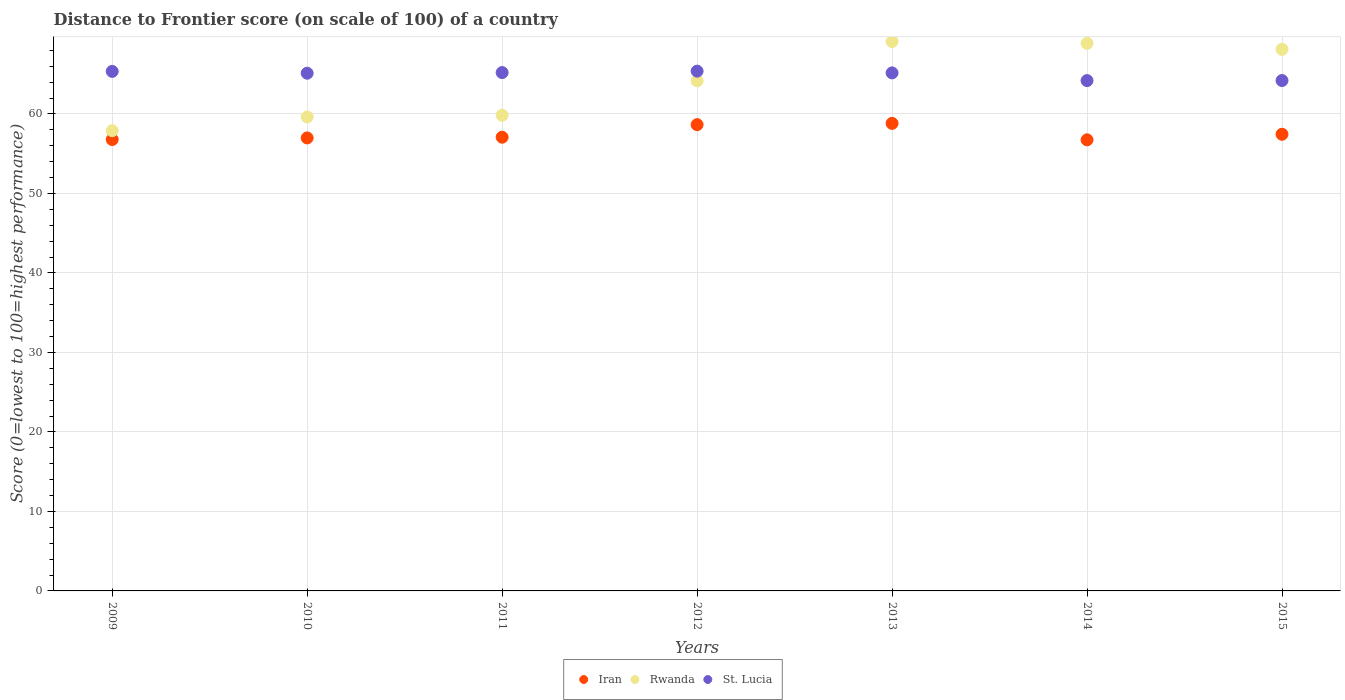How many different coloured dotlines are there?
Ensure brevity in your answer.  3. Is the number of dotlines equal to the number of legend labels?
Offer a terse response. Yes. What is the distance to frontier score of in Rwanda in 2012?
Your answer should be compact. 64.17. Across all years, what is the maximum distance to frontier score of in St. Lucia?
Ensure brevity in your answer.  65.38. Across all years, what is the minimum distance to frontier score of in St. Lucia?
Your response must be concise. 64.19. In which year was the distance to frontier score of in St. Lucia minimum?
Keep it short and to the point. 2014. What is the total distance to frontier score of in Iran in the graph?
Provide a succinct answer. 402.47. What is the difference between the distance to frontier score of in Rwanda in 2009 and that in 2011?
Provide a short and direct response. -1.94. What is the difference between the distance to frontier score of in St. Lucia in 2011 and the distance to frontier score of in Iran in 2012?
Your response must be concise. 6.55. What is the average distance to frontier score of in Rwanda per year?
Ensure brevity in your answer.  63.95. In the year 2011, what is the difference between the distance to frontier score of in St. Lucia and distance to frontier score of in Rwanda?
Ensure brevity in your answer.  5.37. In how many years, is the distance to frontier score of in St. Lucia greater than 6?
Provide a succinct answer. 7. What is the ratio of the distance to frontier score of in Rwanda in 2013 to that in 2015?
Keep it short and to the point. 1.01. What is the difference between the highest and the second highest distance to frontier score of in Rwanda?
Your response must be concise. 0.23. What is the difference between the highest and the lowest distance to frontier score of in St. Lucia?
Give a very brief answer. 1.19. Is the sum of the distance to frontier score of in Rwanda in 2010 and 2014 greater than the maximum distance to frontier score of in Iran across all years?
Keep it short and to the point. Yes. Is it the case that in every year, the sum of the distance to frontier score of in Rwanda and distance to frontier score of in St. Lucia  is greater than the distance to frontier score of in Iran?
Keep it short and to the point. Yes. Does the distance to frontier score of in Iran monotonically increase over the years?
Provide a short and direct response. No. Is the distance to frontier score of in Rwanda strictly less than the distance to frontier score of in St. Lucia over the years?
Provide a succinct answer. No. How many dotlines are there?
Give a very brief answer. 3. Does the graph contain any zero values?
Provide a short and direct response. No. How many legend labels are there?
Provide a succinct answer. 3. How are the legend labels stacked?
Ensure brevity in your answer.  Horizontal. What is the title of the graph?
Your answer should be compact. Distance to Frontier score (on scale of 100) of a country. Does "Sao Tome and Principe" appear as one of the legend labels in the graph?
Offer a terse response. No. What is the label or title of the Y-axis?
Provide a succinct answer. Score (0=lowest to 100=highest performance). What is the Score (0=lowest to 100=highest performance) of Iran in 2009?
Offer a very short reply. 56.78. What is the Score (0=lowest to 100=highest performance) in Rwanda in 2009?
Ensure brevity in your answer.  57.89. What is the Score (0=lowest to 100=highest performance) of St. Lucia in 2009?
Your answer should be compact. 65.35. What is the Score (0=lowest to 100=highest performance) in Iran in 2010?
Make the answer very short. 56.98. What is the Score (0=lowest to 100=highest performance) in Rwanda in 2010?
Ensure brevity in your answer.  59.62. What is the Score (0=lowest to 100=highest performance) of St. Lucia in 2010?
Your response must be concise. 65.12. What is the Score (0=lowest to 100=highest performance) of Iran in 2011?
Your answer should be compact. 57.07. What is the Score (0=lowest to 100=highest performance) in Rwanda in 2011?
Provide a short and direct response. 59.83. What is the Score (0=lowest to 100=highest performance) of St. Lucia in 2011?
Ensure brevity in your answer.  65.2. What is the Score (0=lowest to 100=highest performance) of Iran in 2012?
Keep it short and to the point. 58.65. What is the Score (0=lowest to 100=highest performance) in Rwanda in 2012?
Provide a short and direct response. 64.17. What is the Score (0=lowest to 100=highest performance) in St. Lucia in 2012?
Your answer should be very brief. 65.38. What is the Score (0=lowest to 100=highest performance) in Iran in 2013?
Give a very brief answer. 58.81. What is the Score (0=lowest to 100=highest performance) in Rwanda in 2013?
Make the answer very short. 69.11. What is the Score (0=lowest to 100=highest performance) in St. Lucia in 2013?
Your answer should be compact. 65.16. What is the Score (0=lowest to 100=highest performance) in Iran in 2014?
Your answer should be compact. 56.74. What is the Score (0=lowest to 100=highest performance) of Rwanda in 2014?
Keep it short and to the point. 68.88. What is the Score (0=lowest to 100=highest performance) in St. Lucia in 2014?
Your answer should be very brief. 64.19. What is the Score (0=lowest to 100=highest performance) of Iran in 2015?
Offer a very short reply. 57.44. What is the Score (0=lowest to 100=highest performance) in Rwanda in 2015?
Your response must be concise. 68.12. What is the Score (0=lowest to 100=highest performance) of St. Lucia in 2015?
Offer a very short reply. 64.2. Across all years, what is the maximum Score (0=lowest to 100=highest performance) in Iran?
Provide a short and direct response. 58.81. Across all years, what is the maximum Score (0=lowest to 100=highest performance) in Rwanda?
Ensure brevity in your answer.  69.11. Across all years, what is the maximum Score (0=lowest to 100=highest performance) in St. Lucia?
Provide a short and direct response. 65.38. Across all years, what is the minimum Score (0=lowest to 100=highest performance) in Iran?
Give a very brief answer. 56.74. Across all years, what is the minimum Score (0=lowest to 100=highest performance) in Rwanda?
Your answer should be very brief. 57.89. Across all years, what is the minimum Score (0=lowest to 100=highest performance) in St. Lucia?
Make the answer very short. 64.19. What is the total Score (0=lowest to 100=highest performance) of Iran in the graph?
Keep it short and to the point. 402.47. What is the total Score (0=lowest to 100=highest performance) in Rwanda in the graph?
Provide a succinct answer. 447.62. What is the total Score (0=lowest to 100=highest performance) of St. Lucia in the graph?
Your answer should be compact. 454.6. What is the difference between the Score (0=lowest to 100=highest performance) of Rwanda in 2009 and that in 2010?
Make the answer very short. -1.73. What is the difference between the Score (0=lowest to 100=highest performance) in St. Lucia in 2009 and that in 2010?
Provide a succinct answer. 0.23. What is the difference between the Score (0=lowest to 100=highest performance) of Iran in 2009 and that in 2011?
Provide a succinct answer. -0.29. What is the difference between the Score (0=lowest to 100=highest performance) in Rwanda in 2009 and that in 2011?
Your answer should be compact. -1.94. What is the difference between the Score (0=lowest to 100=highest performance) in St. Lucia in 2009 and that in 2011?
Your answer should be very brief. 0.15. What is the difference between the Score (0=lowest to 100=highest performance) of Iran in 2009 and that in 2012?
Make the answer very short. -1.87. What is the difference between the Score (0=lowest to 100=highest performance) in Rwanda in 2009 and that in 2012?
Provide a succinct answer. -6.28. What is the difference between the Score (0=lowest to 100=highest performance) of St. Lucia in 2009 and that in 2012?
Offer a terse response. -0.03. What is the difference between the Score (0=lowest to 100=highest performance) in Iran in 2009 and that in 2013?
Provide a succinct answer. -2.03. What is the difference between the Score (0=lowest to 100=highest performance) in Rwanda in 2009 and that in 2013?
Your answer should be compact. -11.22. What is the difference between the Score (0=lowest to 100=highest performance) in St. Lucia in 2009 and that in 2013?
Your response must be concise. 0.19. What is the difference between the Score (0=lowest to 100=highest performance) of Rwanda in 2009 and that in 2014?
Provide a succinct answer. -10.99. What is the difference between the Score (0=lowest to 100=highest performance) in St. Lucia in 2009 and that in 2014?
Offer a terse response. 1.16. What is the difference between the Score (0=lowest to 100=highest performance) in Iran in 2009 and that in 2015?
Your response must be concise. -0.66. What is the difference between the Score (0=lowest to 100=highest performance) in Rwanda in 2009 and that in 2015?
Make the answer very short. -10.23. What is the difference between the Score (0=lowest to 100=highest performance) of St. Lucia in 2009 and that in 2015?
Make the answer very short. 1.15. What is the difference between the Score (0=lowest to 100=highest performance) of Iran in 2010 and that in 2011?
Your answer should be very brief. -0.09. What is the difference between the Score (0=lowest to 100=highest performance) in Rwanda in 2010 and that in 2011?
Provide a short and direct response. -0.21. What is the difference between the Score (0=lowest to 100=highest performance) in St. Lucia in 2010 and that in 2011?
Offer a terse response. -0.08. What is the difference between the Score (0=lowest to 100=highest performance) in Iran in 2010 and that in 2012?
Keep it short and to the point. -1.67. What is the difference between the Score (0=lowest to 100=highest performance) in Rwanda in 2010 and that in 2012?
Your answer should be very brief. -4.55. What is the difference between the Score (0=lowest to 100=highest performance) of St. Lucia in 2010 and that in 2012?
Offer a terse response. -0.26. What is the difference between the Score (0=lowest to 100=highest performance) in Iran in 2010 and that in 2013?
Your answer should be compact. -1.83. What is the difference between the Score (0=lowest to 100=highest performance) of Rwanda in 2010 and that in 2013?
Your answer should be very brief. -9.49. What is the difference between the Score (0=lowest to 100=highest performance) of St. Lucia in 2010 and that in 2013?
Your answer should be very brief. -0.04. What is the difference between the Score (0=lowest to 100=highest performance) in Iran in 2010 and that in 2014?
Your answer should be very brief. 0.24. What is the difference between the Score (0=lowest to 100=highest performance) of Rwanda in 2010 and that in 2014?
Offer a very short reply. -9.26. What is the difference between the Score (0=lowest to 100=highest performance) of St. Lucia in 2010 and that in 2014?
Provide a succinct answer. 0.93. What is the difference between the Score (0=lowest to 100=highest performance) of Iran in 2010 and that in 2015?
Your response must be concise. -0.46. What is the difference between the Score (0=lowest to 100=highest performance) in St. Lucia in 2010 and that in 2015?
Provide a short and direct response. 0.92. What is the difference between the Score (0=lowest to 100=highest performance) of Iran in 2011 and that in 2012?
Offer a terse response. -1.58. What is the difference between the Score (0=lowest to 100=highest performance) of Rwanda in 2011 and that in 2012?
Give a very brief answer. -4.34. What is the difference between the Score (0=lowest to 100=highest performance) in St. Lucia in 2011 and that in 2012?
Provide a short and direct response. -0.18. What is the difference between the Score (0=lowest to 100=highest performance) in Iran in 2011 and that in 2013?
Offer a terse response. -1.74. What is the difference between the Score (0=lowest to 100=highest performance) of Rwanda in 2011 and that in 2013?
Ensure brevity in your answer.  -9.28. What is the difference between the Score (0=lowest to 100=highest performance) of St. Lucia in 2011 and that in 2013?
Offer a very short reply. 0.04. What is the difference between the Score (0=lowest to 100=highest performance) of Iran in 2011 and that in 2014?
Give a very brief answer. 0.33. What is the difference between the Score (0=lowest to 100=highest performance) in Rwanda in 2011 and that in 2014?
Make the answer very short. -9.05. What is the difference between the Score (0=lowest to 100=highest performance) of St. Lucia in 2011 and that in 2014?
Your response must be concise. 1.01. What is the difference between the Score (0=lowest to 100=highest performance) of Iran in 2011 and that in 2015?
Provide a succinct answer. -0.37. What is the difference between the Score (0=lowest to 100=highest performance) in Rwanda in 2011 and that in 2015?
Give a very brief answer. -8.29. What is the difference between the Score (0=lowest to 100=highest performance) in Iran in 2012 and that in 2013?
Offer a very short reply. -0.16. What is the difference between the Score (0=lowest to 100=highest performance) of Rwanda in 2012 and that in 2013?
Provide a short and direct response. -4.94. What is the difference between the Score (0=lowest to 100=highest performance) of St. Lucia in 2012 and that in 2013?
Offer a terse response. 0.22. What is the difference between the Score (0=lowest to 100=highest performance) in Iran in 2012 and that in 2014?
Keep it short and to the point. 1.91. What is the difference between the Score (0=lowest to 100=highest performance) in Rwanda in 2012 and that in 2014?
Your answer should be compact. -4.71. What is the difference between the Score (0=lowest to 100=highest performance) of St. Lucia in 2012 and that in 2014?
Keep it short and to the point. 1.19. What is the difference between the Score (0=lowest to 100=highest performance) of Iran in 2012 and that in 2015?
Provide a succinct answer. 1.21. What is the difference between the Score (0=lowest to 100=highest performance) of Rwanda in 2012 and that in 2015?
Make the answer very short. -3.95. What is the difference between the Score (0=lowest to 100=highest performance) in St. Lucia in 2012 and that in 2015?
Offer a terse response. 1.18. What is the difference between the Score (0=lowest to 100=highest performance) of Iran in 2013 and that in 2014?
Offer a very short reply. 2.07. What is the difference between the Score (0=lowest to 100=highest performance) in Rwanda in 2013 and that in 2014?
Provide a short and direct response. 0.23. What is the difference between the Score (0=lowest to 100=highest performance) in Iran in 2013 and that in 2015?
Your answer should be compact. 1.37. What is the difference between the Score (0=lowest to 100=highest performance) in Rwanda in 2013 and that in 2015?
Provide a succinct answer. 0.99. What is the difference between the Score (0=lowest to 100=highest performance) in Iran in 2014 and that in 2015?
Your answer should be compact. -0.7. What is the difference between the Score (0=lowest to 100=highest performance) of Rwanda in 2014 and that in 2015?
Offer a terse response. 0.76. What is the difference between the Score (0=lowest to 100=highest performance) of St. Lucia in 2014 and that in 2015?
Provide a succinct answer. -0.01. What is the difference between the Score (0=lowest to 100=highest performance) in Iran in 2009 and the Score (0=lowest to 100=highest performance) in Rwanda in 2010?
Ensure brevity in your answer.  -2.84. What is the difference between the Score (0=lowest to 100=highest performance) in Iran in 2009 and the Score (0=lowest to 100=highest performance) in St. Lucia in 2010?
Offer a very short reply. -8.34. What is the difference between the Score (0=lowest to 100=highest performance) of Rwanda in 2009 and the Score (0=lowest to 100=highest performance) of St. Lucia in 2010?
Make the answer very short. -7.23. What is the difference between the Score (0=lowest to 100=highest performance) of Iran in 2009 and the Score (0=lowest to 100=highest performance) of Rwanda in 2011?
Give a very brief answer. -3.05. What is the difference between the Score (0=lowest to 100=highest performance) in Iran in 2009 and the Score (0=lowest to 100=highest performance) in St. Lucia in 2011?
Your response must be concise. -8.42. What is the difference between the Score (0=lowest to 100=highest performance) in Rwanda in 2009 and the Score (0=lowest to 100=highest performance) in St. Lucia in 2011?
Make the answer very short. -7.31. What is the difference between the Score (0=lowest to 100=highest performance) of Iran in 2009 and the Score (0=lowest to 100=highest performance) of Rwanda in 2012?
Your answer should be compact. -7.39. What is the difference between the Score (0=lowest to 100=highest performance) in Iran in 2009 and the Score (0=lowest to 100=highest performance) in St. Lucia in 2012?
Give a very brief answer. -8.6. What is the difference between the Score (0=lowest to 100=highest performance) in Rwanda in 2009 and the Score (0=lowest to 100=highest performance) in St. Lucia in 2012?
Your answer should be very brief. -7.49. What is the difference between the Score (0=lowest to 100=highest performance) in Iran in 2009 and the Score (0=lowest to 100=highest performance) in Rwanda in 2013?
Provide a succinct answer. -12.33. What is the difference between the Score (0=lowest to 100=highest performance) of Iran in 2009 and the Score (0=lowest to 100=highest performance) of St. Lucia in 2013?
Ensure brevity in your answer.  -8.38. What is the difference between the Score (0=lowest to 100=highest performance) of Rwanda in 2009 and the Score (0=lowest to 100=highest performance) of St. Lucia in 2013?
Keep it short and to the point. -7.27. What is the difference between the Score (0=lowest to 100=highest performance) of Iran in 2009 and the Score (0=lowest to 100=highest performance) of St. Lucia in 2014?
Offer a very short reply. -7.41. What is the difference between the Score (0=lowest to 100=highest performance) in Rwanda in 2009 and the Score (0=lowest to 100=highest performance) in St. Lucia in 2014?
Your answer should be very brief. -6.3. What is the difference between the Score (0=lowest to 100=highest performance) in Iran in 2009 and the Score (0=lowest to 100=highest performance) in Rwanda in 2015?
Your response must be concise. -11.34. What is the difference between the Score (0=lowest to 100=highest performance) of Iran in 2009 and the Score (0=lowest to 100=highest performance) of St. Lucia in 2015?
Your answer should be very brief. -7.42. What is the difference between the Score (0=lowest to 100=highest performance) in Rwanda in 2009 and the Score (0=lowest to 100=highest performance) in St. Lucia in 2015?
Offer a very short reply. -6.31. What is the difference between the Score (0=lowest to 100=highest performance) in Iran in 2010 and the Score (0=lowest to 100=highest performance) in Rwanda in 2011?
Your answer should be compact. -2.85. What is the difference between the Score (0=lowest to 100=highest performance) in Iran in 2010 and the Score (0=lowest to 100=highest performance) in St. Lucia in 2011?
Keep it short and to the point. -8.22. What is the difference between the Score (0=lowest to 100=highest performance) in Rwanda in 2010 and the Score (0=lowest to 100=highest performance) in St. Lucia in 2011?
Give a very brief answer. -5.58. What is the difference between the Score (0=lowest to 100=highest performance) in Iran in 2010 and the Score (0=lowest to 100=highest performance) in Rwanda in 2012?
Provide a succinct answer. -7.19. What is the difference between the Score (0=lowest to 100=highest performance) of Iran in 2010 and the Score (0=lowest to 100=highest performance) of St. Lucia in 2012?
Make the answer very short. -8.4. What is the difference between the Score (0=lowest to 100=highest performance) of Rwanda in 2010 and the Score (0=lowest to 100=highest performance) of St. Lucia in 2012?
Give a very brief answer. -5.76. What is the difference between the Score (0=lowest to 100=highest performance) in Iran in 2010 and the Score (0=lowest to 100=highest performance) in Rwanda in 2013?
Your response must be concise. -12.13. What is the difference between the Score (0=lowest to 100=highest performance) in Iran in 2010 and the Score (0=lowest to 100=highest performance) in St. Lucia in 2013?
Provide a succinct answer. -8.18. What is the difference between the Score (0=lowest to 100=highest performance) of Rwanda in 2010 and the Score (0=lowest to 100=highest performance) of St. Lucia in 2013?
Your answer should be compact. -5.54. What is the difference between the Score (0=lowest to 100=highest performance) in Iran in 2010 and the Score (0=lowest to 100=highest performance) in Rwanda in 2014?
Provide a succinct answer. -11.9. What is the difference between the Score (0=lowest to 100=highest performance) in Iran in 2010 and the Score (0=lowest to 100=highest performance) in St. Lucia in 2014?
Offer a terse response. -7.21. What is the difference between the Score (0=lowest to 100=highest performance) in Rwanda in 2010 and the Score (0=lowest to 100=highest performance) in St. Lucia in 2014?
Make the answer very short. -4.57. What is the difference between the Score (0=lowest to 100=highest performance) in Iran in 2010 and the Score (0=lowest to 100=highest performance) in Rwanda in 2015?
Provide a short and direct response. -11.14. What is the difference between the Score (0=lowest to 100=highest performance) in Iran in 2010 and the Score (0=lowest to 100=highest performance) in St. Lucia in 2015?
Your response must be concise. -7.22. What is the difference between the Score (0=lowest to 100=highest performance) in Rwanda in 2010 and the Score (0=lowest to 100=highest performance) in St. Lucia in 2015?
Offer a terse response. -4.58. What is the difference between the Score (0=lowest to 100=highest performance) of Iran in 2011 and the Score (0=lowest to 100=highest performance) of Rwanda in 2012?
Your response must be concise. -7.1. What is the difference between the Score (0=lowest to 100=highest performance) in Iran in 2011 and the Score (0=lowest to 100=highest performance) in St. Lucia in 2012?
Keep it short and to the point. -8.31. What is the difference between the Score (0=lowest to 100=highest performance) of Rwanda in 2011 and the Score (0=lowest to 100=highest performance) of St. Lucia in 2012?
Your answer should be very brief. -5.55. What is the difference between the Score (0=lowest to 100=highest performance) of Iran in 2011 and the Score (0=lowest to 100=highest performance) of Rwanda in 2013?
Offer a terse response. -12.04. What is the difference between the Score (0=lowest to 100=highest performance) in Iran in 2011 and the Score (0=lowest to 100=highest performance) in St. Lucia in 2013?
Keep it short and to the point. -8.09. What is the difference between the Score (0=lowest to 100=highest performance) in Rwanda in 2011 and the Score (0=lowest to 100=highest performance) in St. Lucia in 2013?
Make the answer very short. -5.33. What is the difference between the Score (0=lowest to 100=highest performance) of Iran in 2011 and the Score (0=lowest to 100=highest performance) of Rwanda in 2014?
Provide a succinct answer. -11.81. What is the difference between the Score (0=lowest to 100=highest performance) in Iran in 2011 and the Score (0=lowest to 100=highest performance) in St. Lucia in 2014?
Give a very brief answer. -7.12. What is the difference between the Score (0=lowest to 100=highest performance) in Rwanda in 2011 and the Score (0=lowest to 100=highest performance) in St. Lucia in 2014?
Provide a succinct answer. -4.36. What is the difference between the Score (0=lowest to 100=highest performance) of Iran in 2011 and the Score (0=lowest to 100=highest performance) of Rwanda in 2015?
Provide a succinct answer. -11.05. What is the difference between the Score (0=lowest to 100=highest performance) of Iran in 2011 and the Score (0=lowest to 100=highest performance) of St. Lucia in 2015?
Offer a very short reply. -7.13. What is the difference between the Score (0=lowest to 100=highest performance) of Rwanda in 2011 and the Score (0=lowest to 100=highest performance) of St. Lucia in 2015?
Your answer should be compact. -4.37. What is the difference between the Score (0=lowest to 100=highest performance) of Iran in 2012 and the Score (0=lowest to 100=highest performance) of Rwanda in 2013?
Provide a short and direct response. -10.46. What is the difference between the Score (0=lowest to 100=highest performance) in Iran in 2012 and the Score (0=lowest to 100=highest performance) in St. Lucia in 2013?
Your answer should be compact. -6.51. What is the difference between the Score (0=lowest to 100=highest performance) in Rwanda in 2012 and the Score (0=lowest to 100=highest performance) in St. Lucia in 2013?
Give a very brief answer. -0.99. What is the difference between the Score (0=lowest to 100=highest performance) in Iran in 2012 and the Score (0=lowest to 100=highest performance) in Rwanda in 2014?
Your response must be concise. -10.23. What is the difference between the Score (0=lowest to 100=highest performance) in Iran in 2012 and the Score (0=lowest to 100=highest performance) in St. Lucia in 2014?
Offer a very short reply. -5.54. What is the difference between the Score (0=lowest to 100=highest performance) in Rwanda in 2012 and the Score (0=lowest to 100=highest performance) in St. Lucia in 2014?
Make the answer very short. -0.02. What is the difference between the Score (0=lowest to 100=highest performance) in Iran in 2012 and the Score (0=lowest to 100=highest performance) in Rwanda in 2015?
Offer a terse response. -9.47. What is the difference between the Score (0=lowest to 100=highest performance) of Iran in 2012 and the Score (0=lowest to 100=highest performance) of St. Lucia in 2015?
Your response must be concise. -5.55. What is the difference between the Score (0=lowest to 100=highest performance) of Rwanda in 2012 and the Score (0=lowest to 100=highest performance) of St. Lucia in 2015?
Ensure brevity in your answer.  -0.03. What is the difference between the Score (0=lowest to 100=highest performance) in Iran in 2013 and the Score (0=lowest to 100=highest performance) in Rwanda in 2014?
Offer a terse response. -10.07. What is the difference between the Score (0=lowest to 100=highest performance) in Iran in 2013 and the Score (0=lowest to 100=highest performance) in St. Lucia in 2014?
Keep it short and to the point. -5.38. What is the difference between the Score (0=lowest to 100=highest performance) in Rwanda in 2013 and the Score (0=lowest to 100=highest performance) in St. Lucia in 2014?
Offer a terse response. 4.92. What is the difference between the Score (0=lowest to 100=highest performance) in Iran in 2013 and the Score (0=lowest to 100=highest performance) in Rwanda in 2015?
Provide a succinct answer. -9.31. What is the difference between the Score (0=lowest to 100=highest performance) of Iran in 2013 and the Score (0=lowest to 100=highest performance) of St. Lucia in 2015?
Provide a short and direct response. -5.39. What is the difference between the Score (0=lowest to 100=highest performance) in Rwanda in 2013 and the Score (0=lowest to 100=highest performance) in St. Lucia in 2015?
Provide a short and direct response. 4.91. What is the difference between the Score (0=lowest to 100=highest performance) in Iran in 2014 and the Score (0=lowest to 100=highest performance) in Rwanda in 2015?
Keep it short and to the point. -11.38. What is the difference between the Score (0=lowest to 100=highest performance) of Iran in 2014 and the Score (0=lowest to 100=highest performance) of St. Lucia in 2015?
Keep it short and to the point. -7.46. What is the difference between the Score (0=lowest to 100=highest performance) in Rwanda in 2014 and the Score (0=lowest to 100=highest performance) in St. Lucia in 2015?
Your answer should be very brief. 4.68. What is the average Score (0=lowest to 100=highest performance) in Iran per year?
Provide a short and direct response. 57.5. What is the average Score (0=lowest to 100=highest performance) in Rwanda per year?
Your response must be concise. 63.95. What is the average Score (0=lowest to 100=highest performance) of St. Lucia per year?
Ensure brevity in your answer.  64.94. In the year 2009, what is the difference between the Score (0=lowest to 100=highest performance) in Iran and Score (0=lowest to 100=highest performance) in Rwanda?
Your answer should be very brief. -1.11. In the year 2009, what is the difference between the Score (0=lowest to 100=highest performance) of Iran and Score (0=lowest to 100=highest performance) of St. Lucia?
Provide a short and direct response. -8.57. In the year 2009, what is the difference between the Score (0=lowest to 100=highest performance) of Rwanda and Score (0=lowest to 100=highest performance) of St. Lucia?
Ensure brevity in your answer.  -7.46. In the year 2010, what is the difference between the Score (0=lowest to 100=highest performance) in Iran and Score (0=lowest to 100=highest performance) in Rwanda?
Give a very brief answer. -2.64. In the year 2010, what is the difference between the Score (0=lowest to 100=highest performance) in Iran and Score (0=lowest to 100=highest performance) in St. Lucia?
Your answer should be very brief. -8.14. In the year 2010, what is the difference between the Score (0=lowest to 100=highest performance) of Rwanda and Score (0=lowest to 100=highest performance) of St. Lucia?
Ensure brevity in your answer.  -5.5. In the year 2011, what is the difference between the Score (0=lowest to 100=highest performance) in Iran and Score (0=lowest to 100=highest performance) in Rwanda?
Keep it short and to the point. -2.76. In the year 2011, what is the difference between the Score (0=lowest to 100=highest performance) of Iran and Score (0=lowest to 100=highest performance) of St. Lucia?
Your answer should be very brief. -8.13. In the year 2011, what is the difference between the Score (0=lowest to 100=highest performance) in Rwanda and Score (0=lowest to 100=highest performance) in St. Lucia?
Make the answer very short. -5.37. In the year 2012, what is the difference between the Score (0=lowest to 100=highest performance) of Iran and Score (0=lowest to 100=highest performance) of Rwanda?
Your answer should be very brief. -5.52. In the year 2012, what is the difference between the Score (0=lowest to 100=highest performance) of Iran and Score (0=lowest to 100=highest performance) of St. Lucia?
Provide a short and direct response. -6.73. In the year 2012, what is the difference between the Score (0=lowest to 100=highest performance) in Rwanda and Score (0=lowest to 100=highest performance) in St. Lucia?
Provide a succinct answer. -1.21. In the year 2013, what is the difference between the Score (0=lowest to 100=highest performance) in Iran and Score (0=lowest to 100=highest performance) in St. Lucia?
Provide a short and direct response. -6.35. In the year 2013, what is the difference between the Score (0=lowest to 100=highest performance) in Rwanda and Score (0=lowest to 100=highest performance) in St. Lucia?
Your response must be concise. 3.95. In the year 2014, what is the difference between the Score (0=lowest to 100=highest performance) of Iran and Score (0=lowest to 100=highest performance) of Rwanda?
Provide a succinct answer. -12.14. In the year 2014, what is the difference between the Score (0=lowest to 100=highest performance) of Iran and Score (0=lowest to 100=highest performance) of St. Lucia?
Provide a succinct answer. -7.45. In the year 2014, what is the difference between the Score (0=lowest to 100=highest performance) in Rwanda and Score (0=lowest to 100=highest performance) in St. Lucia?
Your answer should be compact. 4.69. In the year 2015, what is the difference between the Score (0=lowest to 100=highest performance) of Iran and Score (0=lowest to 100=highest performance) of Rwanda?
Your answer should be very brief. -10.68. In the year 2015, what is the difference between the Score (0=lowest to 100=highest performance) in Iran and Score (0=lowest to 100=highest performance) in St. Lucia?
Your answer should be compact. -6.76. In the year 2015, what is the difference between the Score (0=lowest to 100=highest performance) of Rwanda and Score (0=lowest to 100=highest performance) of St. Lucia?
Provide a short and direct response. 3.92. What is the ratio of the Score (0=lowest to 100=highest performance) in Iran in 2009 to that in 2010?
Keep it short and to the point. 1. What is the ratio of the Score (0=lowest to 100=highest performance) in Iran in 2009 to that in 2011?
Your answer should be compact. 0.99. What is the ratio of the Score (0=lowest to 100=highest performance) of Rwanda in 2009 to that in 2011?
Make the answer very short. 0.97. What is the ratio of the Score (0=lowest to 100=highest performance) of Iran in 2009 to that in 2012?
Your answer should be compact. 0.97. What is the ratio of the Score (0=lowest to 100=highest performance) of Rwanda in 2009 to that in 2012?
Offer a very short reply. 0.9. What is the ratio of the Score (0=lowest to 100=highest performance) of Iran in 2009 to that in 2013?
Provide a succinct answer. 0.97. What is the ratio of the Score (0=lowest to 100=highest performance) of Rwanda in 2009 to that in 2013?
Your response must be concise. 0.84. What is the ratio of the Score (0=lowest to 100=highest performance) in Rwanda in 2009 to that in 2014?
Offer a very short reply. 0.84. What is the ratio of the Score (0=lowest to 100=highest performance) of St. Lucia in 2009 to that in 2014?
Your answer should be very brief. 1.02. What is the ratio of the Score (0=lowest to 100=highest performance) in Rwanda in 2009 to that in 2015?
Your answer should be very brief. 0.85. What is the ratio of the Score (0=lowest to 100=highest performance) in St. Lucia in 2009 to that in 2015?
Your response must be concise. 1.02. What is the ratio of the Score (0=lowest to 100=highest performance) in Rwanda in 2010 to that in 2011?
Provide a short and direct response. 1. What is the ratio of the Score (0=lowest to 100=highest performance) of St. Lucia in 2010 to that in 2011?
Offer a very short reply. 1. What is the ratio of the Score (0=lowest to 100=highest performance) of Iran in 2010 to that in 2012?
Your response must be concise. 0.97. What is the ratio of the Score (0=lowest to 100=highest performance) in Rwanda in 2010 to that in 2012?
Provide a succinct answer. 0.93. What is the ratio of the Score (0=lowest to 100=highest performance) of Iran in 2010 to that in 2013?
Ensure brevity in your answer.  0.97. What is the ratio of the Score (0=lowest to 100=highest performance) in Rwanda in 2010 to that in 2013?
Give a very brief answer. 0.86. What is the ratio of the Score (0=lowest to 100=highest performance) of Rwanda in 2010 to that in 2014?
Your answer should be compact. 0.87. What is the ratio of the Score (0=lowest to 100=highest performance) in St. Lucia in 2010 to that in 2014?
Keep it short and to the point. 1.01. What is the ratio of the Score (0=lowest to 100=highest performance) of Iran in 2010 to that in 2015?
Ensure brevity in your answer.  0.99. What is the ratio of the Score (0=lowest to 100=highest performance) of Rwanda in 2010 to that in 2015?
Provide a short and direct response. 0.88. What is the ratio of the Score (0=lowest to 100=highest performance) of St. Lucia in 2010 to that in 2015?
Your response must be concise. 1.01. What is the ratio of the Score (0=lowest to 100=highest performance) in Iran in 2011 to that in 2012?
Offer a very short reply. 0.97. What is the ratio of the Score (0=lowest to 100=highest performance) in Rwanda in 2011 to that in 2012?
Offer a terse response. 0.93. What is the ratio of the Score (0=lowest to 100=highest performance) of Iran in 2011 to that in 2013?
Give a very brief answer. 0.97. What is the ratio of the Score (0=lowest to 100=highest performance) in Rwanda in 2011 to that in 2013?
Make the answer very short. 0.87. What is the ratio of the Score (0=lowest to 100=highest performance) in Rwanda in 2011 to that in 2014?
Your response must be concise. 0.87. What is the ratio of the Score (0=lowest to 100=highest performance) in St. Lucia in 2011 to that in 2014?
Offer a very short reply. 1.02. What is the ratio of the Score (0=lowest to 100=highest performance) of Rwanda in 2011 to that in 2015?
Provide a succinct answer. 0.88. What is the ratio of the Score (0=lowest to 100=highest performance) of St. Lucia in 2011 to that in 2015?
Ensure brevity in your answer.  1.02. What is the ratio of the Score (0=lowest to 100=highest performance) of Rwanda in 2012 to that in 2013?
Offer a terse response. 0.93. What is the ratio of the Score (0=lowest to 100=highest performance) of Iran in 2012 to that in 2014?
Your answer should be very brief. 1.03. What is the ratio of the Score (0=lowest to 100=highest performance) of Rwanda in 2012 to that in 2014?
Ensure brevity in your answer.  0.93. What is the ratio of the Score (0=lowest to 100=highest performance) of St. Lucia in 2012 to that in 2014?
Keep it short and to the point. 1.02. What is the ratio of the Score (0=lowest to 100=highest performance) in Iran in 2012 to that in 2015?
Keep it short and to the point. 1.02. What is the ratio of the Score (0=lowest to 100=highest performance) of Rwanda in 2012 to that in 2015?
Your response must be concise. 0.94. What is the ratio of the Score (0=lowest to 100=highest performance) of St. Lucia in 2012 to that in 2015?
Offer a very short reply. 1.02. What is the ratio of the Score (0=lowest to 100=highest performance) in Iran in 2013 to that in 2014?
Make the answer very short. 1.04. What is the ratio of the Score (0=lowest to 100=highest performance) of Rwanda in 2013 to that in 2014?
Your answer should be compact. 1. What is the ratio of the Score (0=lowest to 100=highest performance) of St. Lucia in 2013 to that in 2014?
Offer a very short reply. 1.02. What is the ratio of the Score (0=lowest to 100=highest performance) in Iran in 2013 to that in 2015?
Offer a very short reply. 1.02. What is the ratio of the Score (0=lowest to 100=highest performance) in Rwanda in 2013 to that in 2015?
Keep it short and to the point. 1.01. What is the ratio of the Score (0=lowest to 100=highest performance) in St. Lucia in 2013 to that in 2015?
Provide a short and direct response. 1.01. What is the ratio of the Score (0=lowest to 100=highest performance) of Rwanda in 2014 to that in 2015?
Ensure brevity in your answer.  1.01. What is the difference between the highest and the second highest Score (0=lowest to 100=highest performance) in Iran?
Provide a succinct answer. 0.16. What is the difference between the highest and the second highest Score (0=lowest to 100=highest performance) in Rwanda?
Ensure brevity in your answer.  0.23. What is the difference between the highest and the second highest Score (0=lowest to 100=highest performance) in St. Lucia?
Provide a short and direct response. 0.03. What is the difference between the highest and the lowest Score (0=lowest to 100=highest performance) of Iran?
Provide a short and direct response. 2.07. What is the difference between the highest and the lowest Score (0=lowest to 100=highest performance) of Rwanda?
Your answer should be compact. 11.22. What is the difference between the highest and the lowest Score (0=lowest to 100=highest performance) in St. Lucia?
Provide a succinct answer. 1.19. 